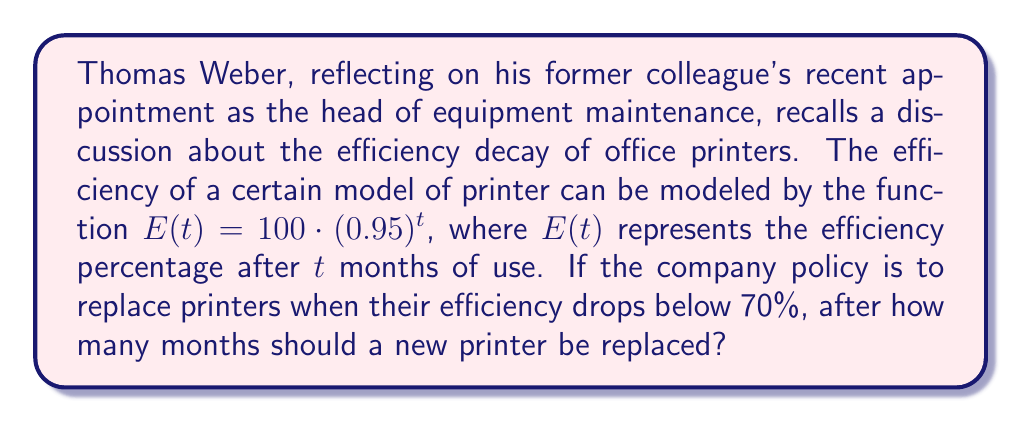Could you help me with this problem? To solve this problem, we need to use the exponential decay formula given and determine when the efficiency drops below 70%. Let's approach this step-by-step:

1) The given function is $E(t) = 100 \cdot (0.95)^t$

2) We want to find $t$ when $E(t) < 70$

3) Let's set up the inequality:
   $100 \cdot (0.95)^t < 70$

4) Divide both sides by 100:
   $(0.95)^t < 0.7$

5) Take the natural log of both sides:
   $\ln((0.95)^t) < \ln(0.7)$

6) Use the log property $\ln(a^b) = b\ln(a)$:
   $t \cdot \ln(0.95) < \ln(0.7)$

7) Divide both sides by $\ln(0.95)$ (note that this flips the inequality because $\ln(0.95)$ is negative):
   $t > \frac{\ln(0.7)}{\ln(0.95)}$

8) Calculate this value:
   $t > \frac{\ln(0.7)}{\ln(0.95)} \approx 6.73$

9) Since we're dealing with whole months, we need to round up to the next integer.

Therefore, the printer should be replaced after 7 months of use.
Answer: 7 months 